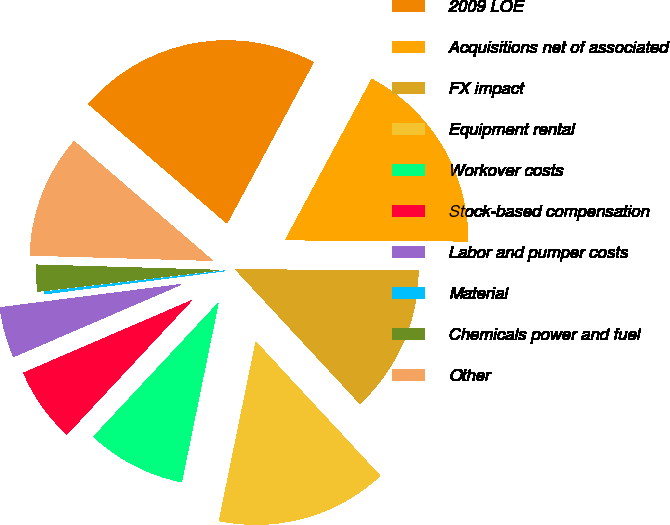Convert chart. <chart><loc_0><loc_0><loc_500><loc_500><pie_chart><fcel>2009 LOE<fcel>Acquisitions net of associated<fcel>FX impact<fcel>Equipment rental<fcel>Workover costs<fcel>Stock-based compensation<fcel>Labor and pumper costs<fcel>Material<fcel>Chemicals power and fuel<fcel>Other<nl><fcel>21.53%<fcel>17.26%<fcel>12.99%<fcel>15.12%<fcel>8.72%<fcel>6.58%<fcel>4.45%<fcel>0.18%<fcel>2.31%<fcel>10.85%<nl></chart> 